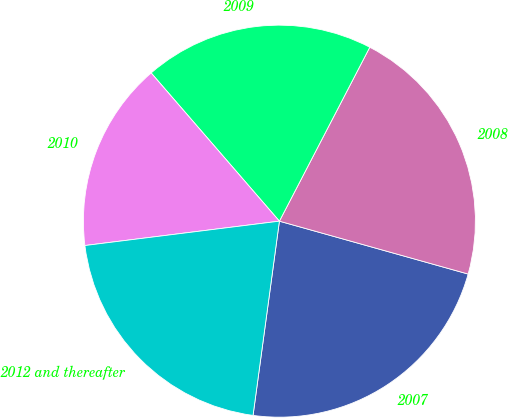Convert chart. <chart><loc_0><loc_0><loc_500><loc_500><pie_chart><fcel>2007<fcel>2008<fcel>2009<fcel>2010<fcel>2012 and thereafter<nl><fcel>22.8%<fcel>21.72%<fcel>18.98%<fcel>15.63%<fcel>20.87%<nl></chart> 